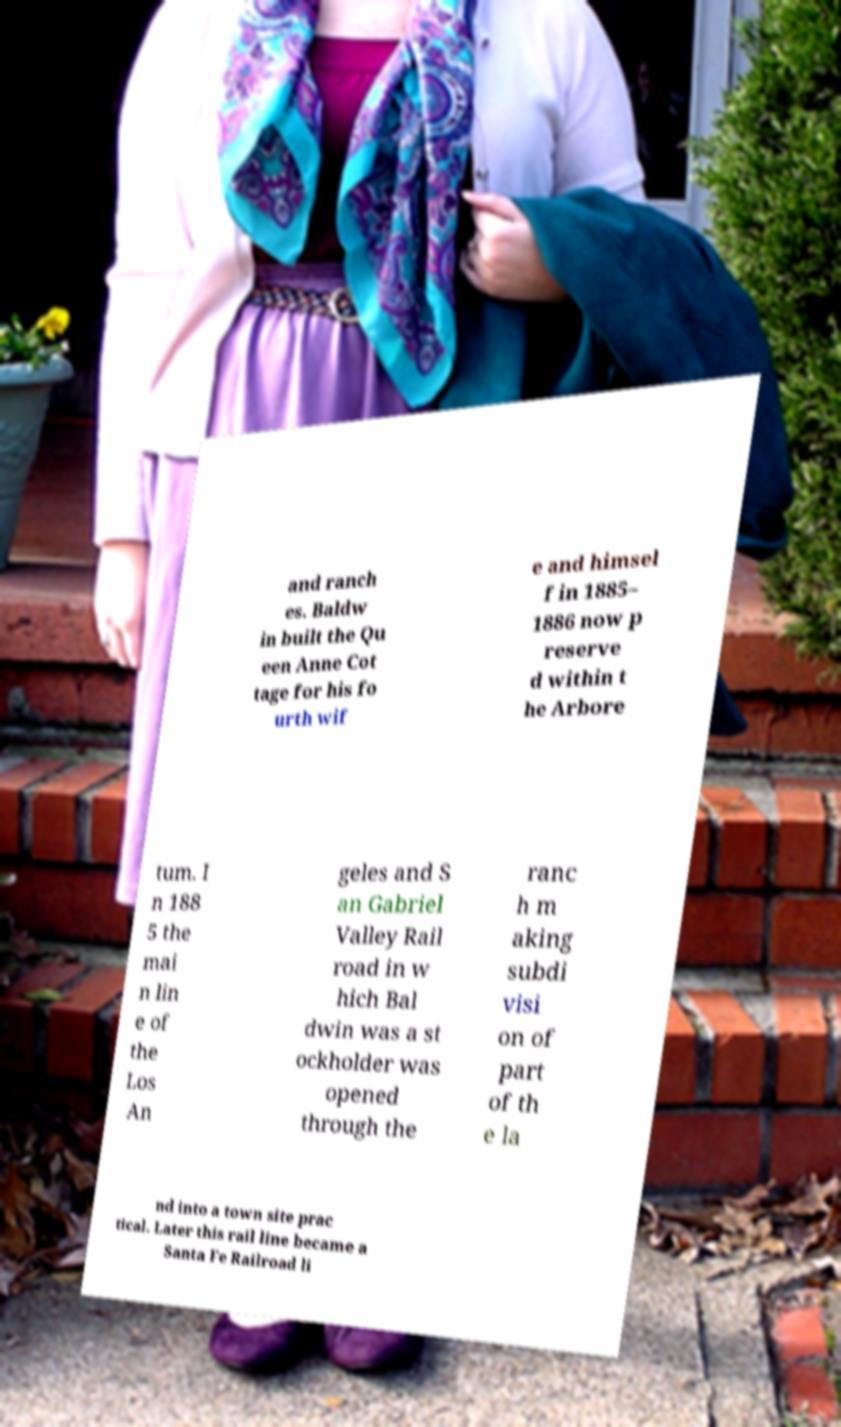Could you assist in decoding the text presented in this image and type it out clearly? and ranch es. Baldw in built the Qu een Anne Cot tage for his fo urth wif e and himsel f in 1885– 1886 now p reserve d within t he Arbore tum. I n 188 5 the mai n lin e of the Los An geles and S an Gabriel Valley Rail road in w hich Bal dwin was a st ockholder was opened through the ranc h m aking subdi visi on of part of th e la nd into a town site prac tical. Later this rail line became a Santa Fe Railroad li 